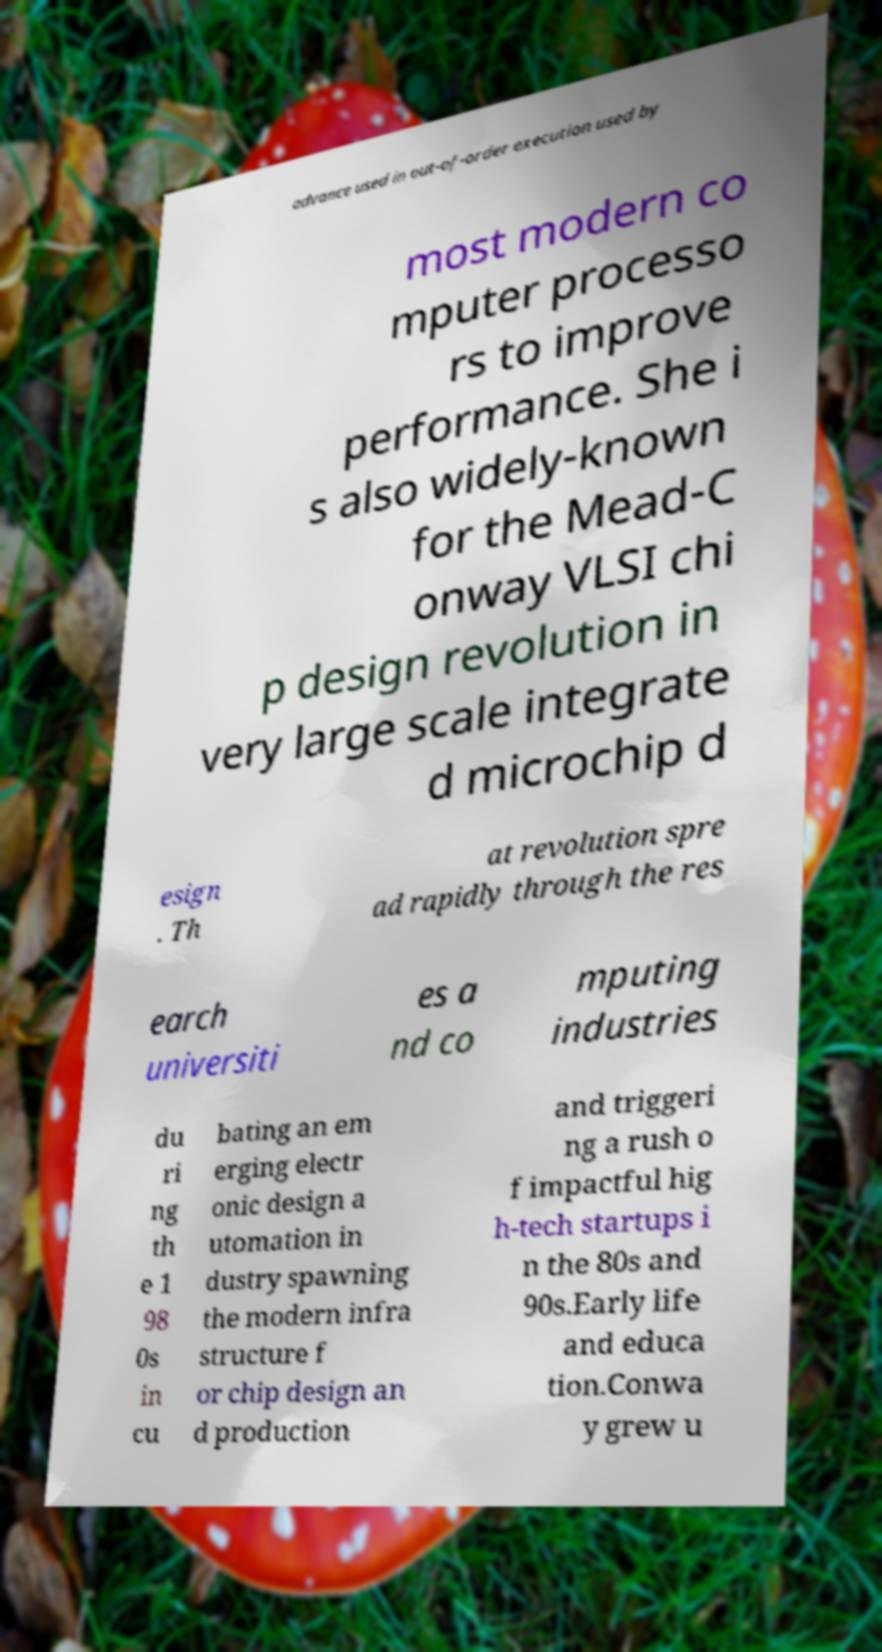Please read and relay the text visible in this image. What does it say? advance used in out-of-order execution used by most modern co mputer processo rs to improve performance. She i s also widely-known for the Mead-C onway VLSI chi p design revolution in very large scale integrate d microchip d esign . Th at revolution spre ad rapidly through the res earch universiti es a nd co mputing industries du ri ng th e 1 98 0s in cu bating an em erging electr onic design a utomation in dustry spawning the modern infra structure f or chip design an d production and triggeri ng a rush o f impactful hig h-tech startups i n the 80s and 90s.Early life and educa tion.Conwa y grew u 